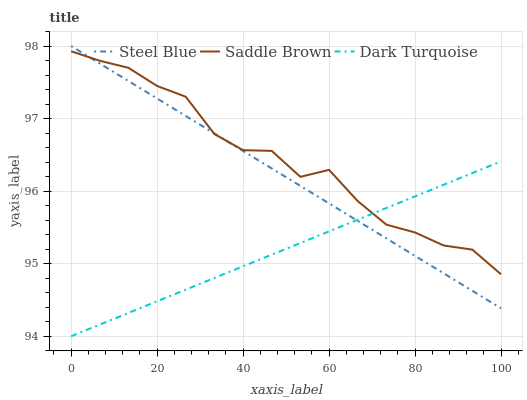Does Steel Blue have the minimum area under the curve?
Answer yes or no. No. Does Steel Blue have the maximum area under the curve?
Answer yes or no. No. Is Steel Blue the smoothest?
Answer yes or no. No. Is Steel Blue the roughest?
Answer yes or no. No. Does Steel Blue have the lowest value?
Answer yes or no. No. Does Saddle Brown have the highest value?
Answer yes or no. No. 